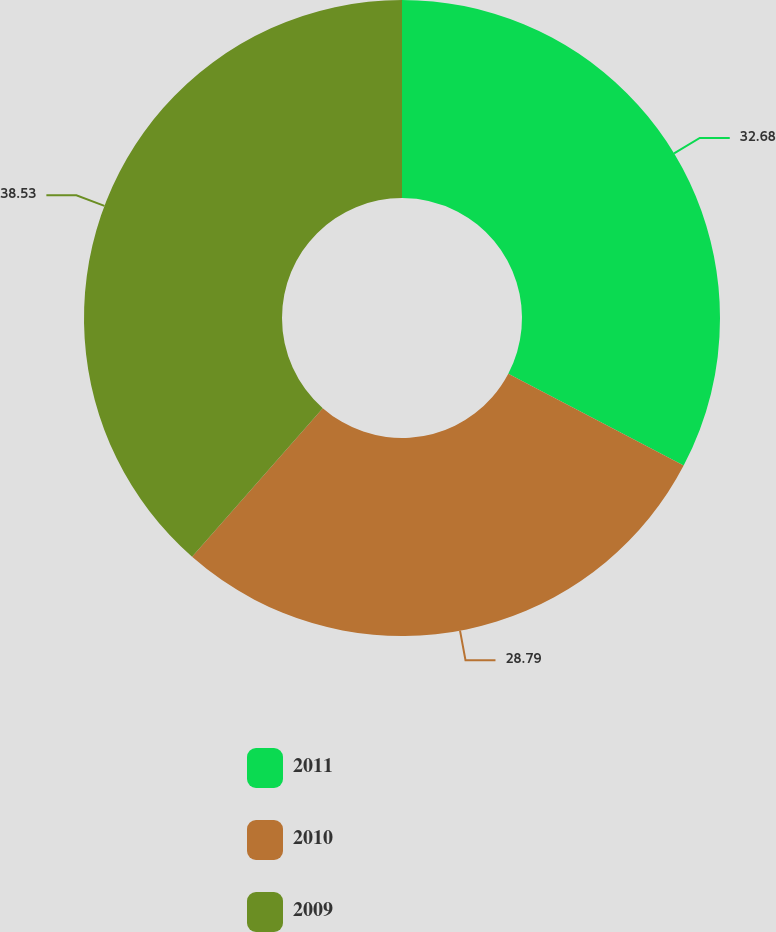Convert chart. <chart><loc_0><loc_0><loc_500><loc_500><pie_chart><fcel>2011<fcel>2010<fcel>2009<nl><fcel>32.68%<fcel>28.79%<fcel>38.52%<nl></chart> 